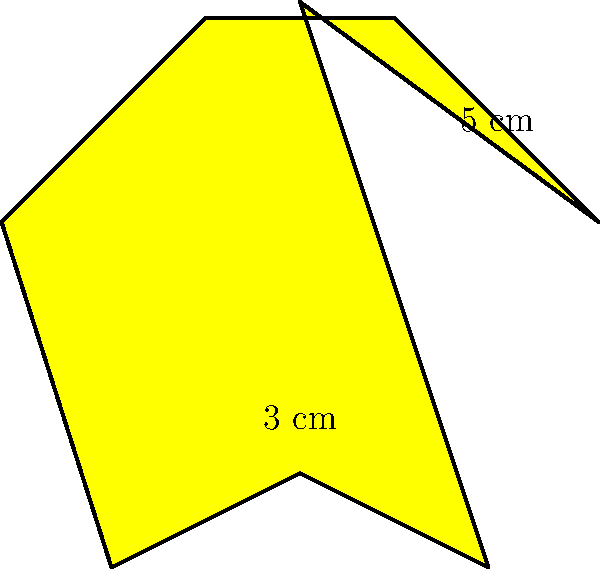A star-shaped award is given to playwrights for their exceptional contributions to theater. The award has 8 points, with each outer edge measuring 5 cm and each inner edge measuring 3 cm. What is the perimeter of this star-shaped award? To find the perimeter of the star-shaped award, we need to calculate the total length of all its edges. Let's break it down step-by-step:

1. Count the number of outer edges:
   The star has 8 points, so it has 8 outer edges.

2. Count the number of inner edges:
   Between each pair of outer edges, there is one inner edge. So, there are also 8 inner edges.

3. Calculate the total length of outer edges:
   Length of outer edges = Number of outer edges × Length of each outer edge
   $8 \times 5 \text{ cm} = 40 \text{ cm}$

4. Calculate the total length of inner edges:
   Length of inner edges = Number of inner edges × Length of each inner edge
   $8 \times 3 \text{ cm} = 24 \text{ cm}$

5. Sum up the total length of all edges:
   Perimeter = Total length of outer edges + Total length of inner edges
   $40 \text{ cm} + 24 \text{ cm} = 64 \text{ cm}$

Therefore, the perimeter of the star-shaped award is 64 cm.
Answer: 64 cm 